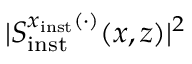<formula> <loc_0><loc_0><loc_500><loc_500>| S _ { i n s t } ^ { x _ { i n s t } ( \cdot ) } ( x , z ) | ^ { 2 }</formula> 